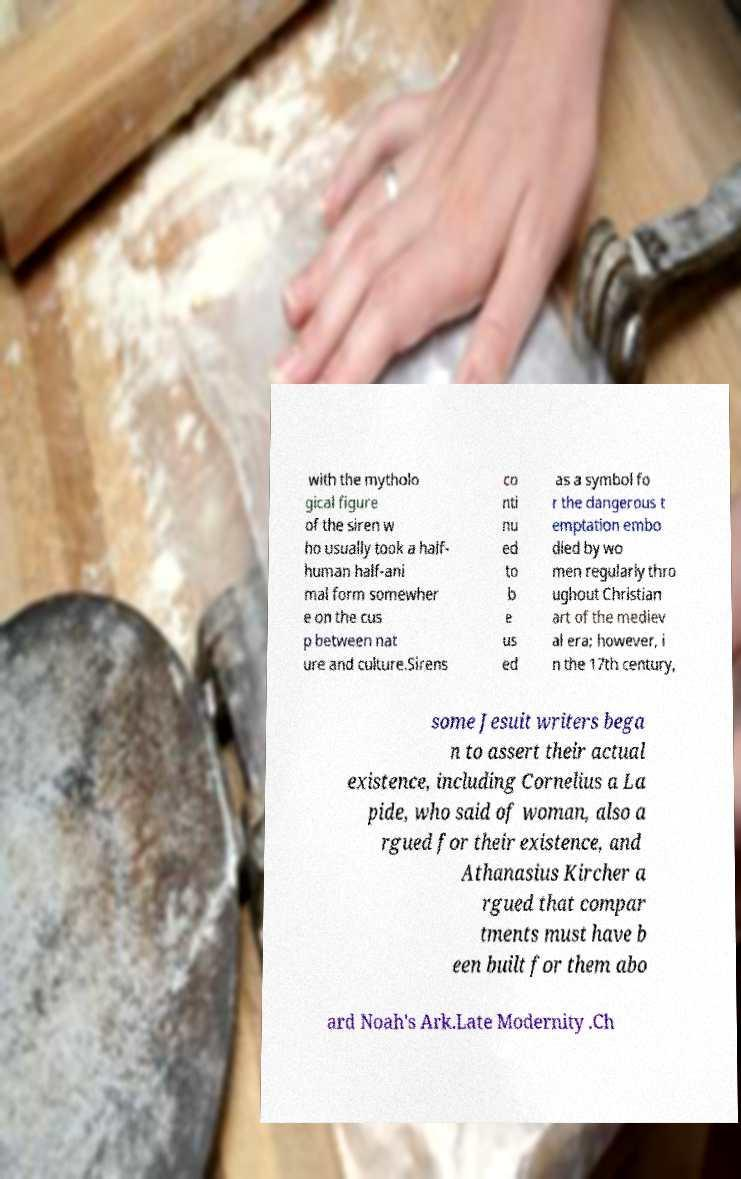Could you assist in decoding the text presented in this image and type it out clearly? with the mytholo gical figure of the siren w ho usually took a half- human half-ani mal form somewher e on the cus p between nat ure and culture.Sirens co nti nu ed to b e us ed as a symbol fo r the dangerous t emptation embo died by wo men regularly thro ughout Christian art of the mediev al era; however, i n the 17th century, some Jesuit writers bega n to assert their actual existence, including Cornelius a La pide, who said of woman, also a rgued for their existence, and Athanasius Kircher a rgued that compar tments must have b een built for them abo ard Noah's Ark.Late Modernity .Ch 